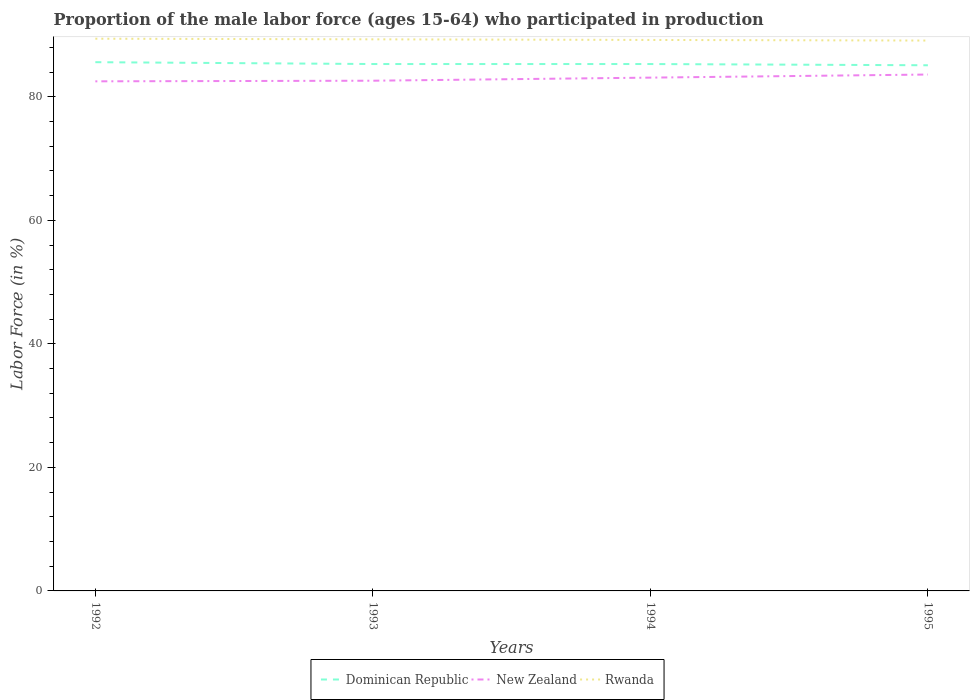How many different coloured lines are there?
Your answer should be very brief. 3. Does the line corresponding to New Zealand intersect with the line corresponding to Rwanda?
Offer a terse response. No. Is the number of lines equal to the number of legend labels?
Keep it short and to the point. Yes. Across all years, what is the maximum proportion of the male labor force who participated in production in Dominican Republic?
Provide a succinct answer. 85.1. In which year was the proportion of the male labor force who participated in production in Rwanda maximum?
Provide a short and direct response. 1995. What is the total proportion of the male labor force who participated in production in Dominican Republic in the graph?
Your answer should be very brief. 0.2. What is the difference between the highest and the second highest proportion of the male labor force who participated in production in New Zealand?
Provide a short and direct response. 1.1. How many lines are there?
Provide a short and direct response. 3. Are the values on the major ticks of Y-axis written in scientific E-notation?
Provide a short and direct response. No. How are the legend labels stacked?
Ensure brevity in your answer.  Horizontal. What is the title of the graph?
Your answer should be compact. Proportion of the male labor force (ages 15-64) who participated in production. What is the Labor Force (in %) in Dominican Republic in 1992?
Provide a succinct answer. 85.6. What is the Labor Force (in %) in New Zealand in 1992?
Offer a terse response. 82.5. What is the Labor Force (in %) of Rwanda in 1992?
Your answer should be very brief. 89.4. What is the Labor Force (in %) in Dominican Republic in 1993?
Give a very brief answer. 85.3. What is the Labor Force (in %) in New Zealand in 1993?
Give a very brief answer. 82.6. What is the Labor Force (in %) of Rwanda in 1993?
Keep it short and to the point. 89.3. What is the Labor Force (in %) of Dominican Republic in 1994?
Provide a succinct answer. 85.3. What is the Labor Force (in %) of New Zealand in 1994?
Make the answer very short. 83.1. What is the Labor Force (in %) in Rwanda in 1994?
Keep it short and to the point. 89.2. What is the Labor Force (in %) in Dominican Republic in 1995?
Your answer should be very brief. 85.1. What is the Labor Force (in %) in New Zealand in 1995?
Keep it short and to the point. 83.6. What is the Labor Force (in %) in Rwanda in 1995?
Your answer should be very brief. 89.1. Across all years, what is the maximum Labor Force (in %) in Dominican Republic?
Provide a short and direct response. 85.6. Across all years, what is the maximum Labor Force (in %) of New Zealand?
Your answer should be compact. 83.6. Across all years, what is the maximum Labor Force (in %) of Rwanda?
Your answer should be compact. 89.4. Across all years, what is the minimum Labor Force (in %) in Dominican Republic?
Give a very brief answer. 85.1. Across all years, what is the minimum Labor Force (in %) of New Zealand?
Your response must be concise. 82.5. Across all years, what is the minimum Labor Force (in %) in Rwanda?
Give a very brief answer. 89.1. What is the total Labor Force (in %) in Dominican Republic in the graph?
Your answer should be compact. 341.3. What is the total Labor Force (in %) of New Zealand in the graph?
Your answer should be very brief. 331.8. What is the total Labor Force (in %) of Rwanda in the graph?
Make the answer very short. 357. What is the difference between the Labor Force (in %) in Dominican Republic in 1992 and that in 1993?
Offer a very short reply. 0.3. What is the difference between the Labor Force (in %) of New Zealand in 1992 and that in 1993?
Give a very brief answer. -0.1. What is the difference between the Labor Force (in %) of Rwanda in 1992 and that in 1993?
Your answer should be compact. 0.1. What is the difference between the Labor Force (in %) in Rwanda in 1993 and that in 1994?
Provide a short and direct response. 0.1. What is the difference between the Labor Force (in %) of Dominican Republic in 1993 and that in 1995?
Make the answer very short. 0.2. What is the difference between the Labor Force (in %) of New Zealand in 1993 and that in 1995?
Provide a short and direct response. -1. What is the difference between the Labor Force (in %) in Rwanda in 1994 and that in 1995?
Your response must be concise. 0.1. What is the difference between the Labor Force (in %) of Dominican Republic in 1992 and the Labor Force (in %) of New Zealand in 1993?
Your answer should be very brief. 3. What is the difference between the Labor Force (in %) of New Zealand in 1992 and the Labor Force (in %) of Rwanda in 1994?
Make the answer very short. -6.7. What is the difference between the Labor Force (in %) of Dominican Republic in 1992 and the Labor Force (in %) of Rwanda in 1995?
Provide a short and direct response. -3.5. What is the difference between the Labor Force (in %) in New Zealand in 1992 and the Labor Force (in %) in Rwanda in 1995?
Offer a very short reply. -6.6. What is the difference between the Labor Force (in %) in Dominican Republic in 1993 and the Labor Force (in %) in New Zealand in 1994?
Your answer should be very brief. 2.2. What is the difference between the Labor Force (in %) of Dominican Republic in 1993 and the Labor Force (in %) of Rwanda in 1994?
Ensure brevity in your answer.  -3.9. What is the difference between the Labor Force (in %) of Dominican Republic in 1994 and the Labor Force (in %) of Rwanda in 1995?
Your response must be concise. -3.8. What is the difference between the Labor Force (in %) in New Zealand in 1994 and the Labor Force (in %) in Rwanda in 1995?
Make the answer very short. -6. What is the average Labor Force (in %) in Dominican Republic per year?
Provide a succinct answer. 85.33. What is the average Labor Force (in %) in New Zealand per year?
Your answer should be very brief. 82.95. What is the average Labor Force (in %) in Rwanda per year?
Keep it short and to the point. 89.25. In the year 1992, what is the difference between the Labor Force (in %) of New Zealand and Labor Force (in %) of Rwanda?
Make the answer very short. -6.9. In the year 1993, what is the difference between the Labor Force (in %) in Dominican Republic and Labor Force (in %) in New Zealand?
Your response must be concise. 2.7. In the year 1993, what is the difference between the Labor Force (in %) of New Zealand and Labor Force (in %) of Rwanda?
Your answer should be compact. -6.7. In the year 1994, what is the difference between the Labor Force (in %) of Dominican Republic and Labor Force (in %) of Rwanda?
Give a very brief answer. -3.9. In the year 1995, what is the difference between the Labor Force (in %) of Dominican Republic and Labor Force (in %) of New Zealand?
Offer a terse response. 1.5. What is the ratio of the Labor Force (in %) in New Zealand in 1992 to that in 1993?
Make the answer very short. 1. What is the ratio of the Labor Force (in %) in Rwanda in 1992 to that in 1993?
Ensure brevity in your answer.  1. What is the ratio of the Labor Force (in %) of New Zealand in 1992 to that in 1994?
Offer a very short reply. 0.99. What is the ratio of the Labor Force (in %) in Dominican Republic in 1992 to that in 1995?
Ensure brevity in your answer.  1.01. What is the ratio of the Labor Force (in %) of Dominican Republic in 1993 to that in 1994?
Keep it short and to the point. 1. What is the ratio of the Labor Force (in %) in Rwanda in 1993 to that in 1994?
Give a very brief answer. 1. What is the ratio of the Labor Force (in %) of New Zealand in 1993 to that in 1995?
Provide a short and direct response. 0.99. What is the ratio of the Labor Force (in %) of Rwanda in 1993 to that in 1995?
Offer a very short reply. 1. What is the difference between the highest and the second highest Labor Force (in %) in Rwanda?
Your response must be concise. 0.1. What is the difference between the highest and the lowest Labor Force (in %) in Rwanda?
Your answer should be very brief. 0.3. 